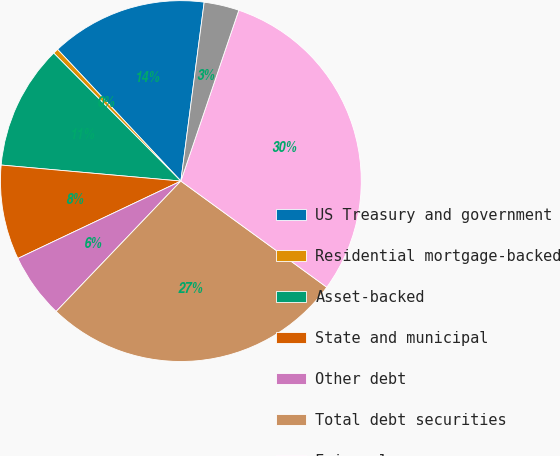Convert chart. <chart><loc_0><loc_0><loc_500><loc_500><pie_chart><fcel>US Treasury and government<fcel>Residential mortgage-backed<fcel>Asset-backed<fcel>State and municipal<fcel>Other debt<fcel>Total debt securities<fcel>Fair value<fcel>Weighted-average yield GAAP<nl><fcel>14.04%<fcel>0.47%<fcel>11.14%<fcel>8.47%<fcel>5.8%<fcel>27.14%<fcel>29.81%<fcel>3.14%<nl></chart> 